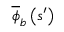Convert formula to latex. <formula><loc_0><loc_0><loc_500><loc_500>\overline { \phi } _ { b } \left ( s ^ { \prime } \right )</formula> 